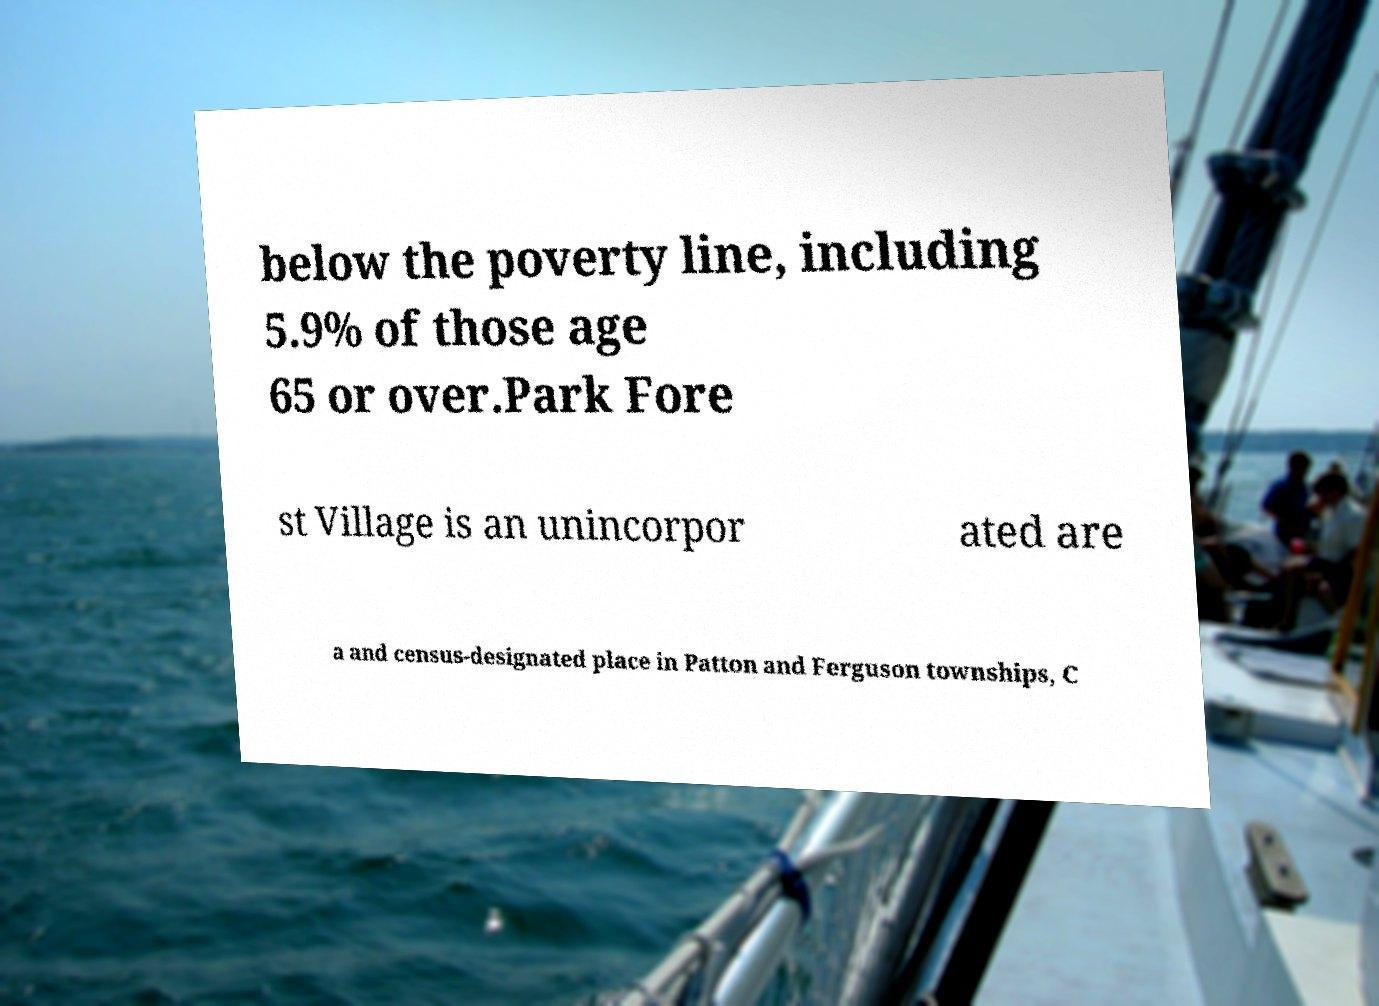Can you accurately transcribe the text from the provided image for me? below the poverty line, including 5.9% of those age 65 or over.Park Fore st Village is an unincorpor ated are a and census-designated place in Patton and Ferguson townships, C 